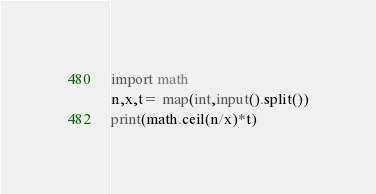<code> <loc_0><loc_0><loc_500><loc_500><_Python_>import math
n,x,t= map(int,input().split())
print(math.ceil(n/x)*t)</code> 